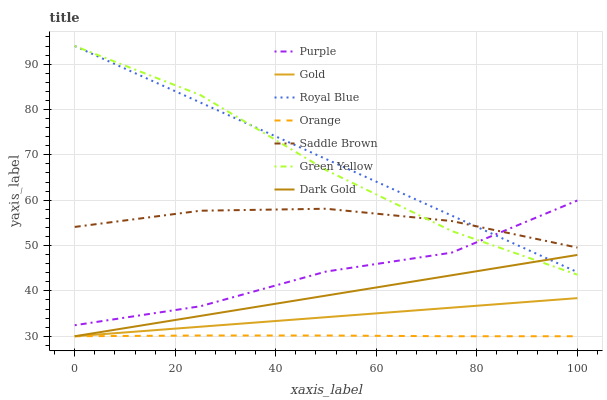Does Orange have the minimum area under the curve?
Answer yes or no. Yes. Does Royal Blue have the maximum area under the curve?
Answer yes or no. Yes. Does Dark Gold have the minimum area under the curve?
Answer yes or no. No. Does Dark Gold have the maximum area under the curve?
Answer yes or no. No. Is Gold the smoothest?
Answer yes or no. Yes. Is Purple the roughest?
Answer yes or no. Yes. Is Dark Gold the smoothest?
Answer yes or no. No. Is Dark Gold the roughest?
Answer yes or no. No. Does Gold have the lowest value?
Answer yes or no. Yes. Does Purple have the lowest value?
Answer yes or no. No. Does Green Yellow have the highest value?
Answer yes or no. Yes. Does Dark Gold have the highest value?
Answer yes or no. No. Is Orange less than Purple?
Answer yes or no. Yes. Is Saddle Brown greater than Gold?
Answer yes or no. Yes. Does Royal Blue intersect Green Yellow?
Answer yes or no. Yes. Is Royal Blue less than Green Yellow?
Answer yes or no. No. Is Royal Blue greater than Green Yellow?
Answer yes or no. No. Does Orange intersect Purple?
Answer yes or no. No. 